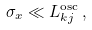<formula> <loc_0><loc_0><loc_500><loc_500>\sigma _ { x } \ll L ^ { \text {osc} } _ { k j } \, ,</formula> 